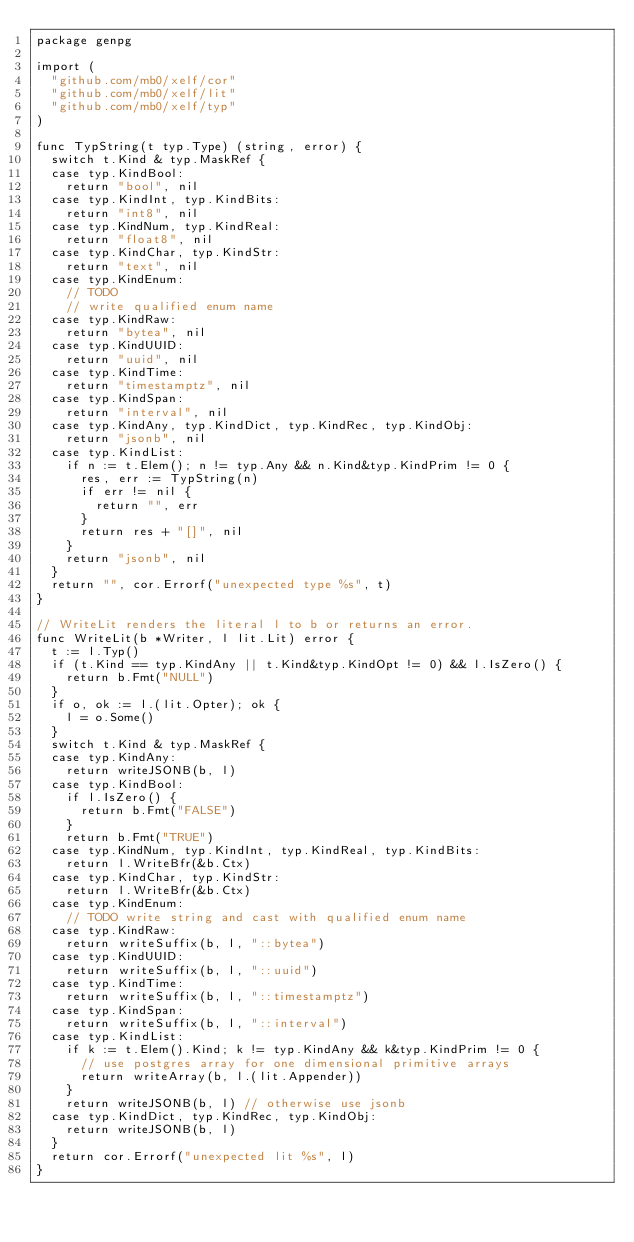Convert code to text. <code><loc_0><loc_0><loc_500><loc_500><_Go_>package genpg

import (
	"github.com/mb0/xelf/cor"
	"github.com/mb0/xelf/lit"
	"github.com/mb0/xelf/typ"
)

func TypString(t typ.Type) (string, error) {
	switch t.Kind & typ.MaskRef {
	case typ.KindBool:
		return "bool", nil
	case typ.KindInt, typ.KindBits:
		return "int8", nil
	case typ.KindNum, typ.KindReal:
		return "float8", nil
	case typ.KindChar, typ.KindStr:
		return "text", nil
	case typ.KindEnum:
		// TODO
		// write qualified enum name
	case typ.KindRaw:
		return "bytea", nil
	case typ.KindUUID:
		return "uuid", nil
	case typ.KindTime:
		return "timestamptz", nil
	case typ.KindSpan:
		return "interval", nil
	case typ.KindAny, typ.KindDict, typ.KindRec, typ.KindObj:
		return "jsonb", nil
	case typ.KindList:
		if n := t.Elem(); n != typ.Any && n.Kind&typ.KindPrim != 0 {
			res, err := TypString(n)
			if err != nil {
				return "", err
			}
			return res + "[]", nil
		}
		return "jsonb", nil
	}
	return "", cor.Errorf("unexpected type %s", t)
}

// WriteLit renders the literal l to b or returns an error.
func WriteLit(b *Writer, l lit.Lit) error {
	t := l.Typ()
	if (t.Kind == typ.KindAny || t.Kind&typ.KindOpt != 0) && l.IsZero() {
		return b.Fmt("NULL")
	}
	if o, ok := l.(lit.Opter); ok {
		l = o.Some()
	}
	switch t.Kind & typ.MaskRef {
	case typ.KindAny:
		return writeJSONB(b, l)
	case typ.KindBool:
		if l.IsZero() {
			return b.Fmt("FALSE")
		}
		return b.Fmt("TRUE")
	case typ.KindNum, typ.KindInt, typ.KindReal, typ.KindBits:
		return l.WriteBfr(&b.Ctx)
	case typ.KindChar, typ.KindStr:
		return l.WriteBfr(&b.Ctx)
	case typ.KindEnum:
		// TODO write string and cast with qualified enum name
	case typ.KindRaw:
		return writeSuffix(b, l, "::bytea")
	case typ.KindUUID:
		return writeSuffix(b, l, "::uuid")
	case typ.KindTime:
		return writeSuffix(b, l, "::timestamptz")
	case typ.KindSpan:
		return writeSuffix(b, l, "::interval")
	case typ.KindList:
		if k := t.Elem().Kind; k != typ.KindAny && k&typ.KindPrim != 0 {
			// use postgres array for one dimensional primitive arrays
			return writeArray(b, l.(lit.Appender))
		}
		return writeJSONB(b, l) // otherwise use jsonb
	case typ.KindDict, typ.KindRec, typ.KindObj:
		return writeJSONB(b, l)
	}
	return cor.Errorf("unexpected lit %s", l)
}
</code> 